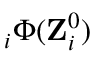Convert formula to latex. <formula><loc_0><loc_0><loc_500><loc_500>{ \nabla } _ { i } \Phi ( { Z } _ { i } ^ { 0 } )</formula> 